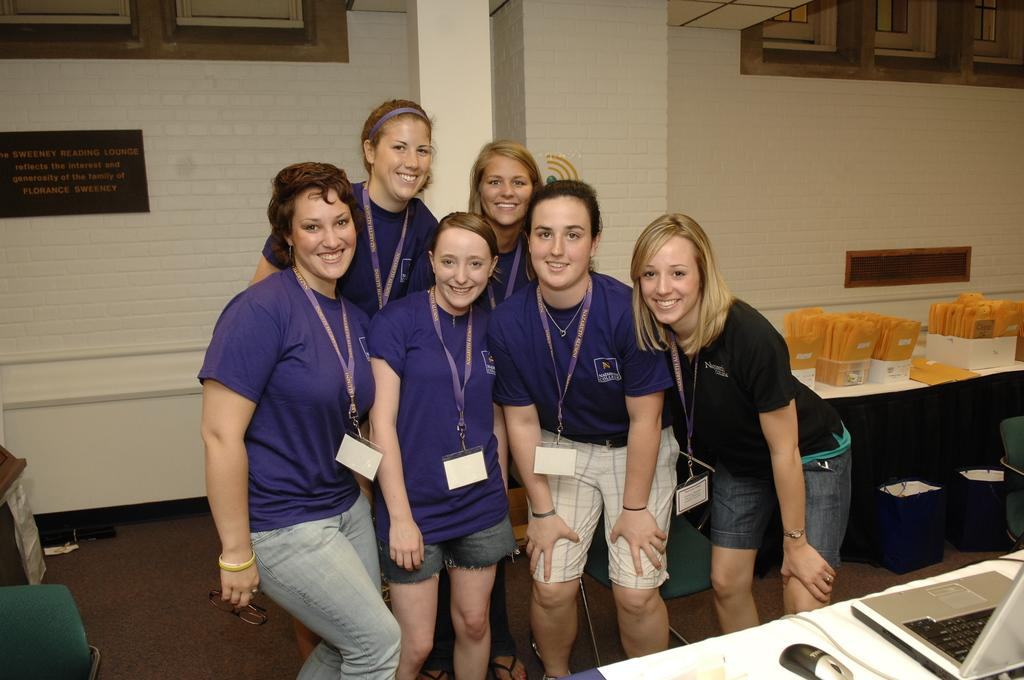How many people are in the image? There is a group of people in the image, but the exact number cannot be determined from the provided facts. What can be seen on the right side of the image? There are objects on a table on the right side of the image. What is visible in the background of the image? There is a wall visible in the background of the image. What arithmetic problem is being solved by the people in the image? There is no indication in the image that the people are solving an arithmetic problem. What historical event is being discussed by the people in the image? There is no indication in the image that the people are discussing any historical event. 